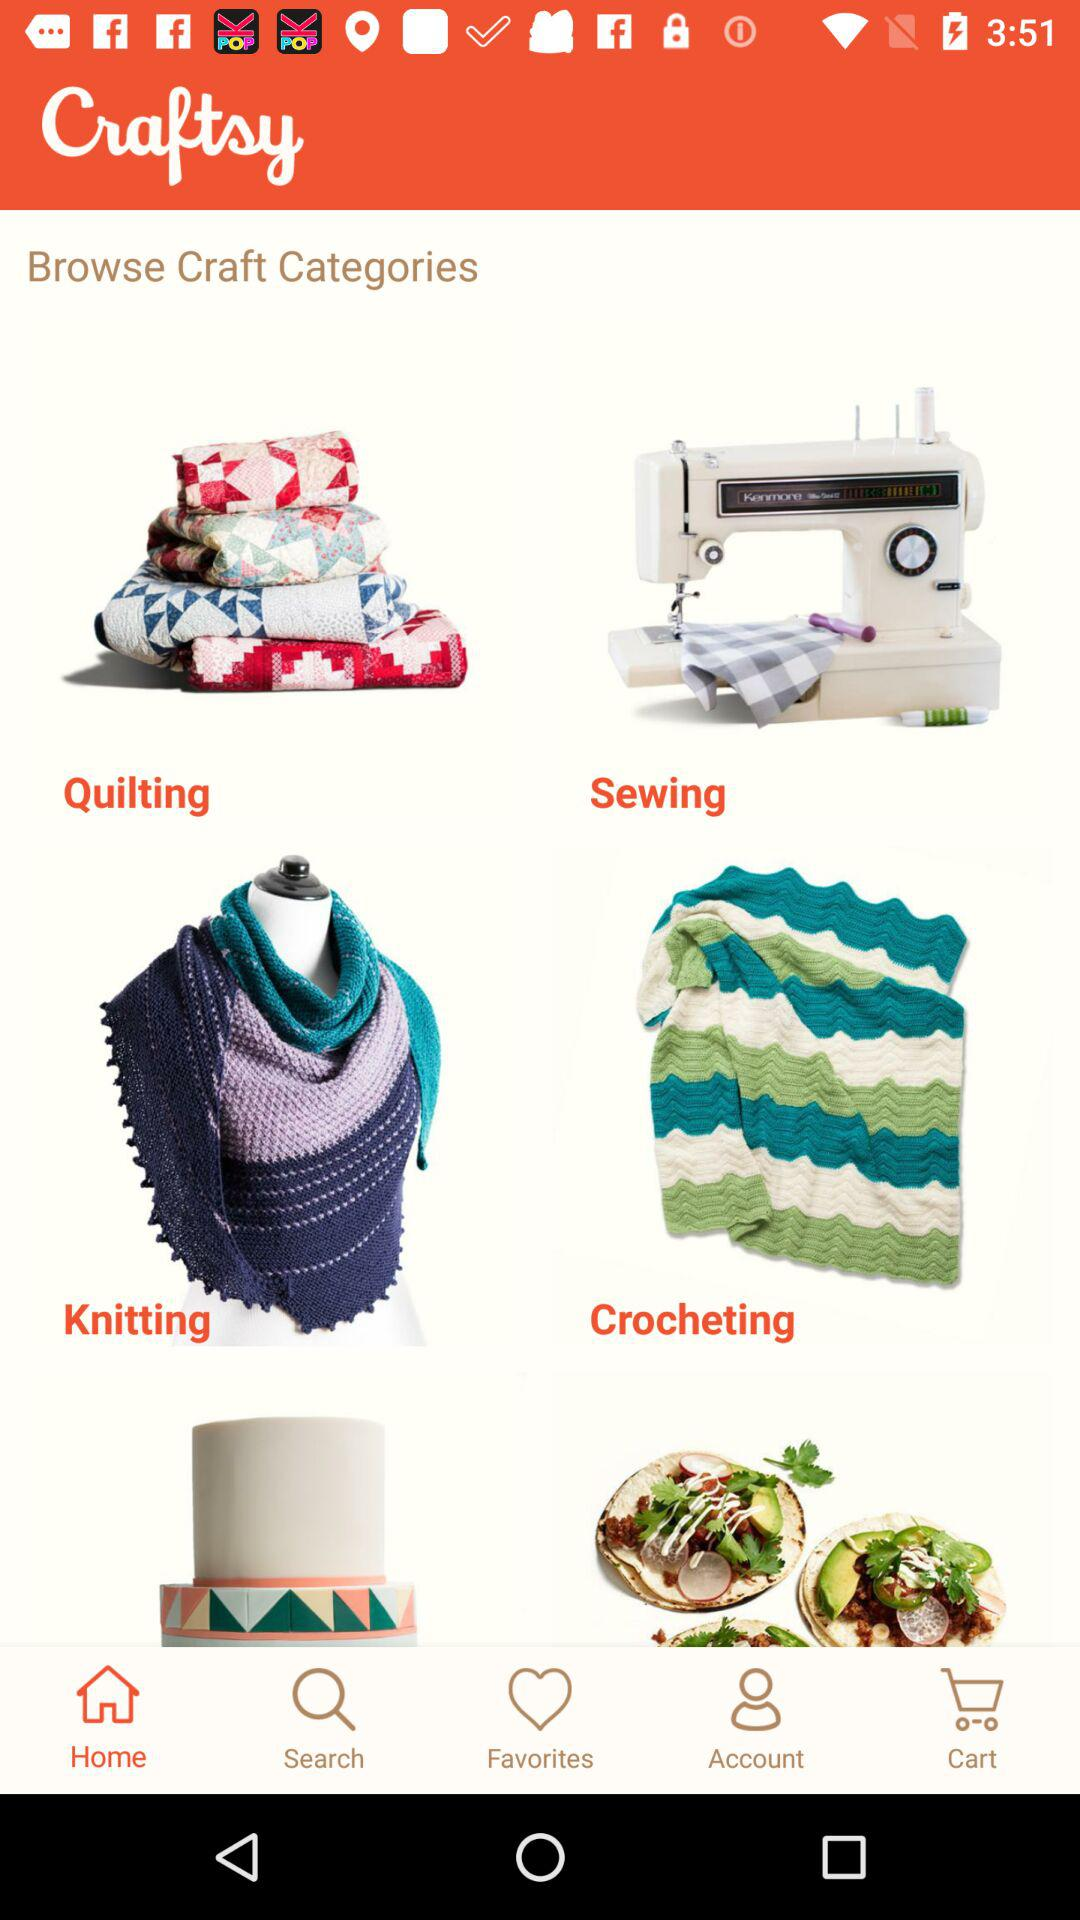Which tab is selected? The selected tab is "Home". 